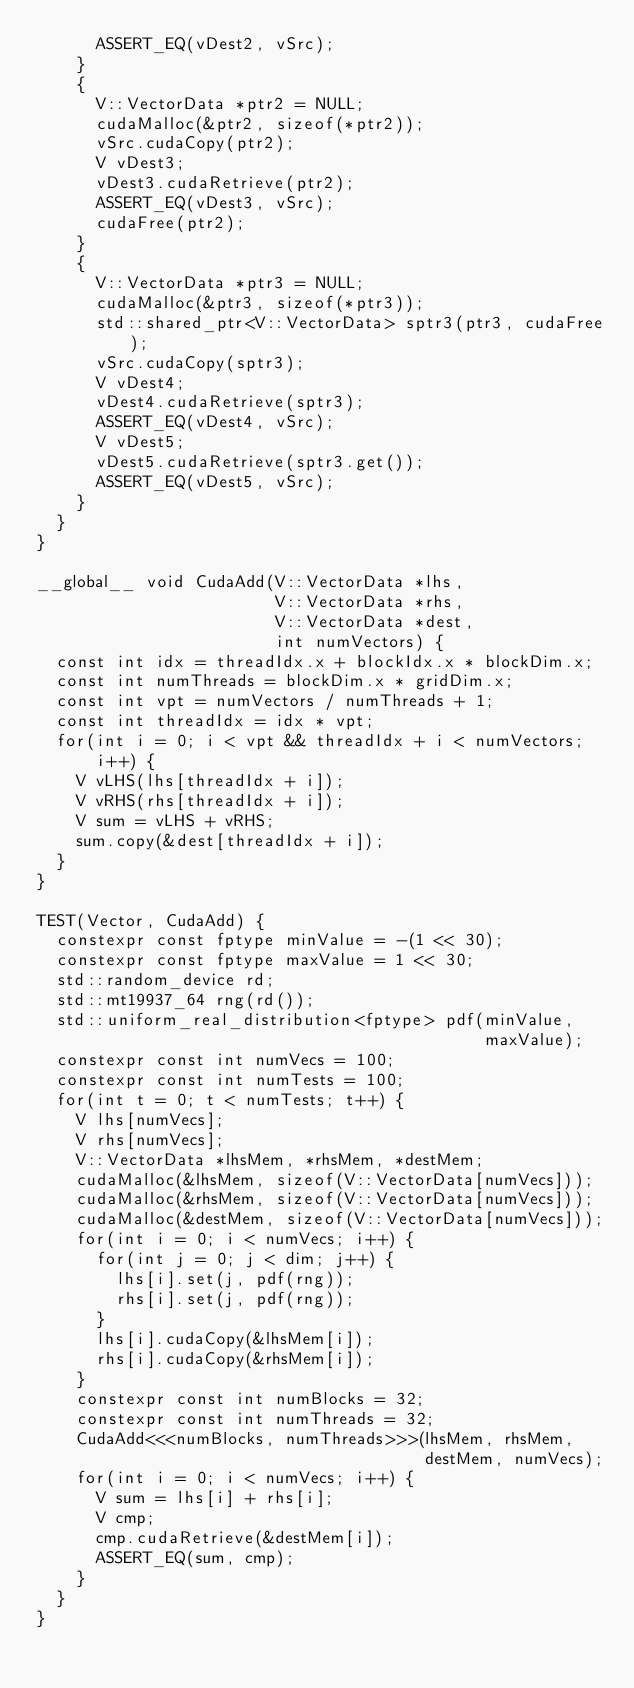<code> <loc_0><loc_0><loc_500><loc_500><_Cuda_>      ASSERT_EQ(vDest2, vSrc);
    }
    {
      V::VectorData *ptr2 = NULL;
      cudaMalloc(&ptr2, sizeof(*ptr2));
      vSrc.cudaCopy(ptr2);
      V vDest3;
      vDest3.cudaRetrieve(ptr2);
      ASSERT_EQ(vDest3, vSrc);
      cudaFree(ptr2);
    }
    {
      V::VectorData *ptr3 = NULL;
      cudaMalloc(&ptr3, sizeof(*ptr3));
      std::shared_ptr<V::VectorData> sptr3(ptr3, cudaFree);
      vSrc.cudaCopy(sptr3);
      V vDest4;
      vDest4.cudaRetrieve(sptr3);
      ASSERT_EQ(vDest4, vSrc);
      V vDest5;
      vDest5.cudaRetrieve(sptr3.get());
      ASSERT_EQ(vDest5, vSrc);
    }
  }
}

__global__ void CudaAdd(V::VectorData *lhs,
                        V::VectorData *rhs,
                        V::VectorData *dest,
                        int numVectors) {
  const int idx = threadIdx.x + blockIdx.x * blockDim.x;
  const int numThreads = blockDim.x * gridDim.x;
  const int vpt = numVectors / numThreads + 1;
  const int threadIdx = idx * vpt;
  for(int i = 0; i < vpt && threadIdx + i < numVectors;
      i++) {
    V vLHS(lhs[threadIdx + i]);
    V vRHS(rhs[threadIdx + i]);
    V sum = vLHS + vRHS;
    sum.copy(&dest[threadIdx + i]);
  }
}

TEST(Vector, CudaAdd) {
  constexpr const fptype minValue = -(1 << 30);
  constexpr const fptype maxValue = 1 << 30;
  std::random_device rd;
  std::mt19937_64 rng(rd());
  std::uniform_real_distribution<fptype> pdf(minValue,
                                             maxValue);
  constexpr const int numVecs = 100;
  constexpr const int numTests = 100;
  for(int t = 0; t < numTests; t++) {
    V lhs[numVecs];
    V rhs[numVecs];
    V::VectorData *lhsMem, *rhsMem, *destMem;
    cudaMalloc(&lhsMem, sizeof(V::VectorData[numVecs]));
    cudaMalloc(&rhsMem, sizeof(V::VectorData[numVecs]));
    cudaMalloc(&destMem, sizeof(V::VectorData[numVecs]));
    for(int i = 0; i < numVecs; i++) {
      for(int j = 0; j < dim; j++) {
        lhs[i].set(j, pdf(rng));
        rhs[i].set(j, pdf(rng));
      }
      lhs[i].cudaCopy(&lhsMem[i]);
      rhs[i].cudaCopy(&rhsMem[i]);
    }
    constexpr const int numBlocks = 32;
    constexpr const int numThreads = 32;
    CudaAdd<<<numBlocks, numThreads>>>(lhsMem, rhsMem,
                                       destMem, numVecs);
    for(int i = 0; i < numVecs; i++) {
      V sum = lhs[i] + rhs[i];
      V cmp;
      cmp.cudaRetrieve(&destMem[i]);
      ASSERT_EQ(sum, cmp);
    }
  }
}
</code> 